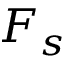<formula> <loc_0><loc_0><loc_500><loc_500>F _ { s }</formula> 